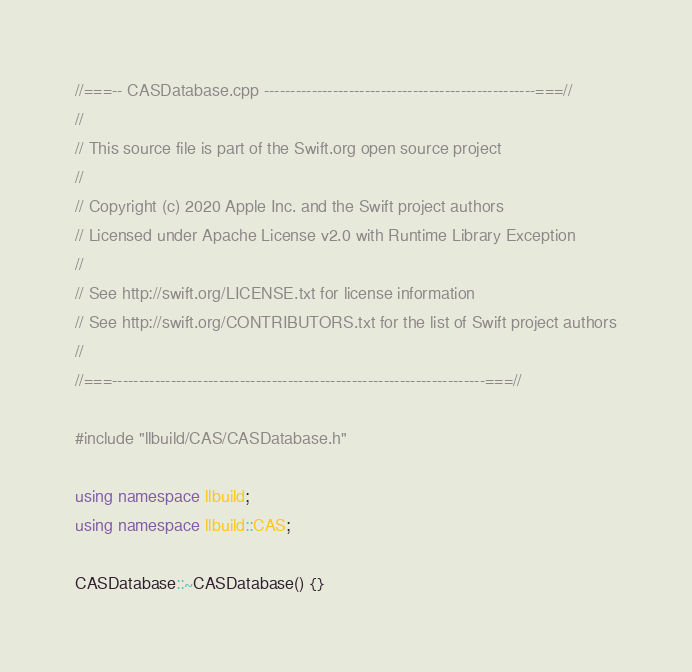<code> <loc_0><loc_0><loc_500><loc_500><_C++_>//===-- CASDatabase.cpp ---------------------------------------------------===//
//
// This source file is part of the Swift.org open source project
//
// Copyright (c) 2020 Apple Inc. and the Swift project authors
// Licensed under Apache License v2.0 with Runtime Library Exception
//
// See http://swift.org/LICENSE.txt for license information
// See http://swift.org/CONTRIBUTORS.txt for the list of Swift project authors
//
//===----------------------------------------------------------------------===//

#include "llbuild/CAS/CASDatabase.h"

using namespace llbuild;
using namespace llbuild::CAS;

CASDatabase::~CASDatabase() {}
</code> 